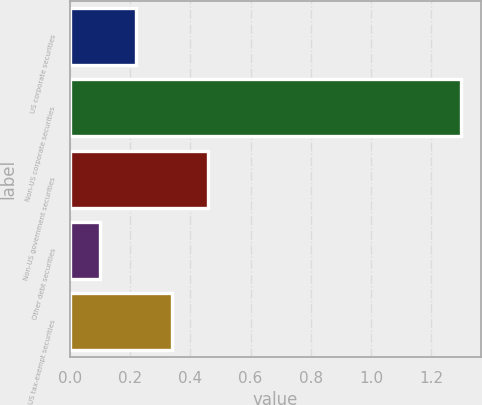Convert chart to OTSL. <chart><loc_0><loc_0><loc_500><loc_500><bar_chart><fcel>US corporate securities<fcel>Non-US corporate securities<fcel>Non-US government securities<fcel>Other debt securities<fcel>US tax-exempt securities<nl><fcel>0.22<fcel>1.3<fcel>0.46<fcel>0.1<fcel>0.34<nl></chart> 